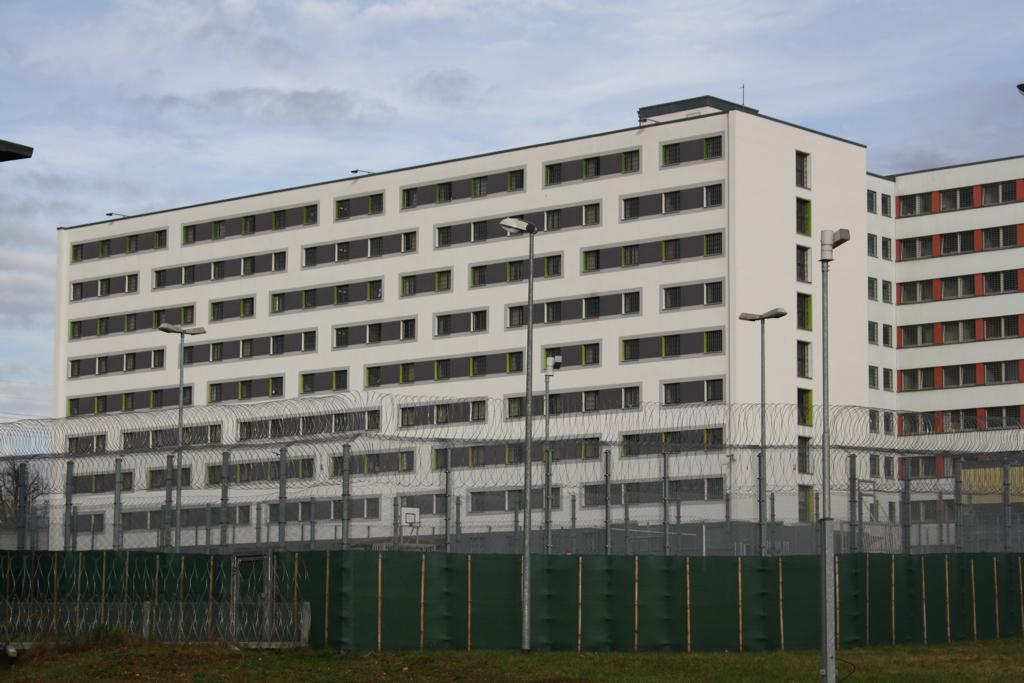What type of structure is present in the image? There is a building in the image. What other objects can be seen in the image? There are poles, lights, and an electric wire fence in the image. What is the ground surface like in the image? There is grass in the image. What can be seen in the background of the image? The sky is visible in the background of the image. What type of skirt is the building wearing in the image? The building is not wearing a skirt, as it is a structure and not a person or living being. 